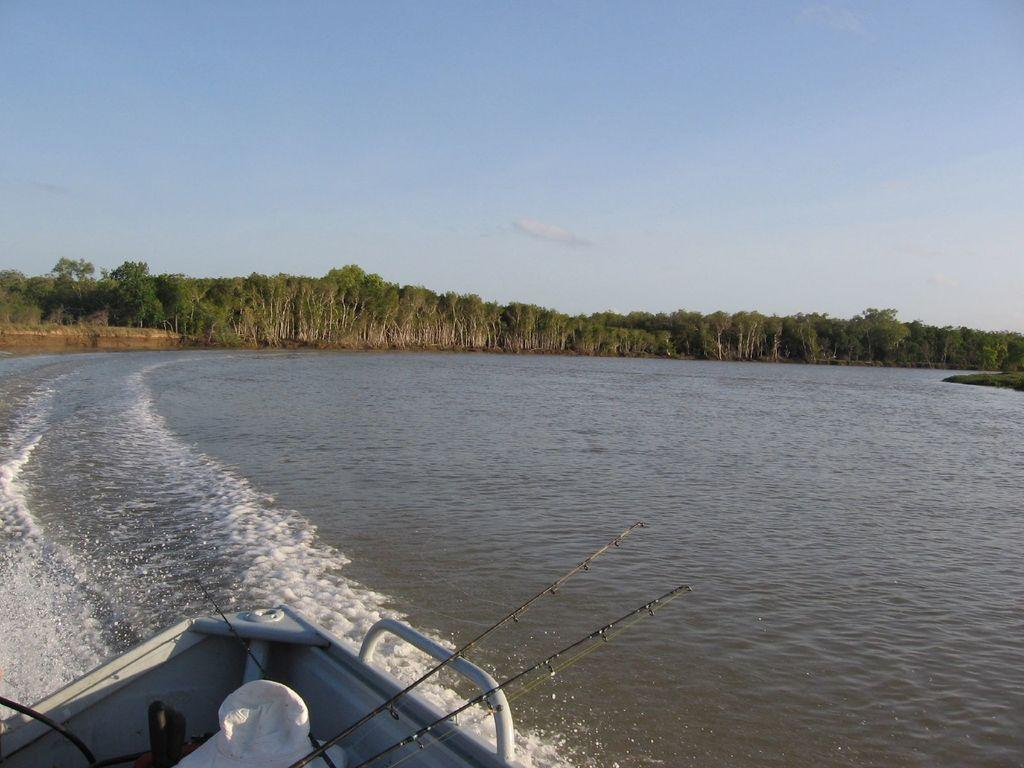What is the main subject in the foreground of the image? There is a boat in the foreground of the image. Where is the boat located? The boat is on a water body. What can be seen in the middle of the image? There are trees in the middle of the image. What is visible at the top of the image? The sky is visible at the top of the image. What type of story is being told by the carriage in the image? There is no carriage present in the image, so no story can be told by a carriage. What type of polish is being used on the boat in the image? There is no indication of any polish being used on the boat in the image. 